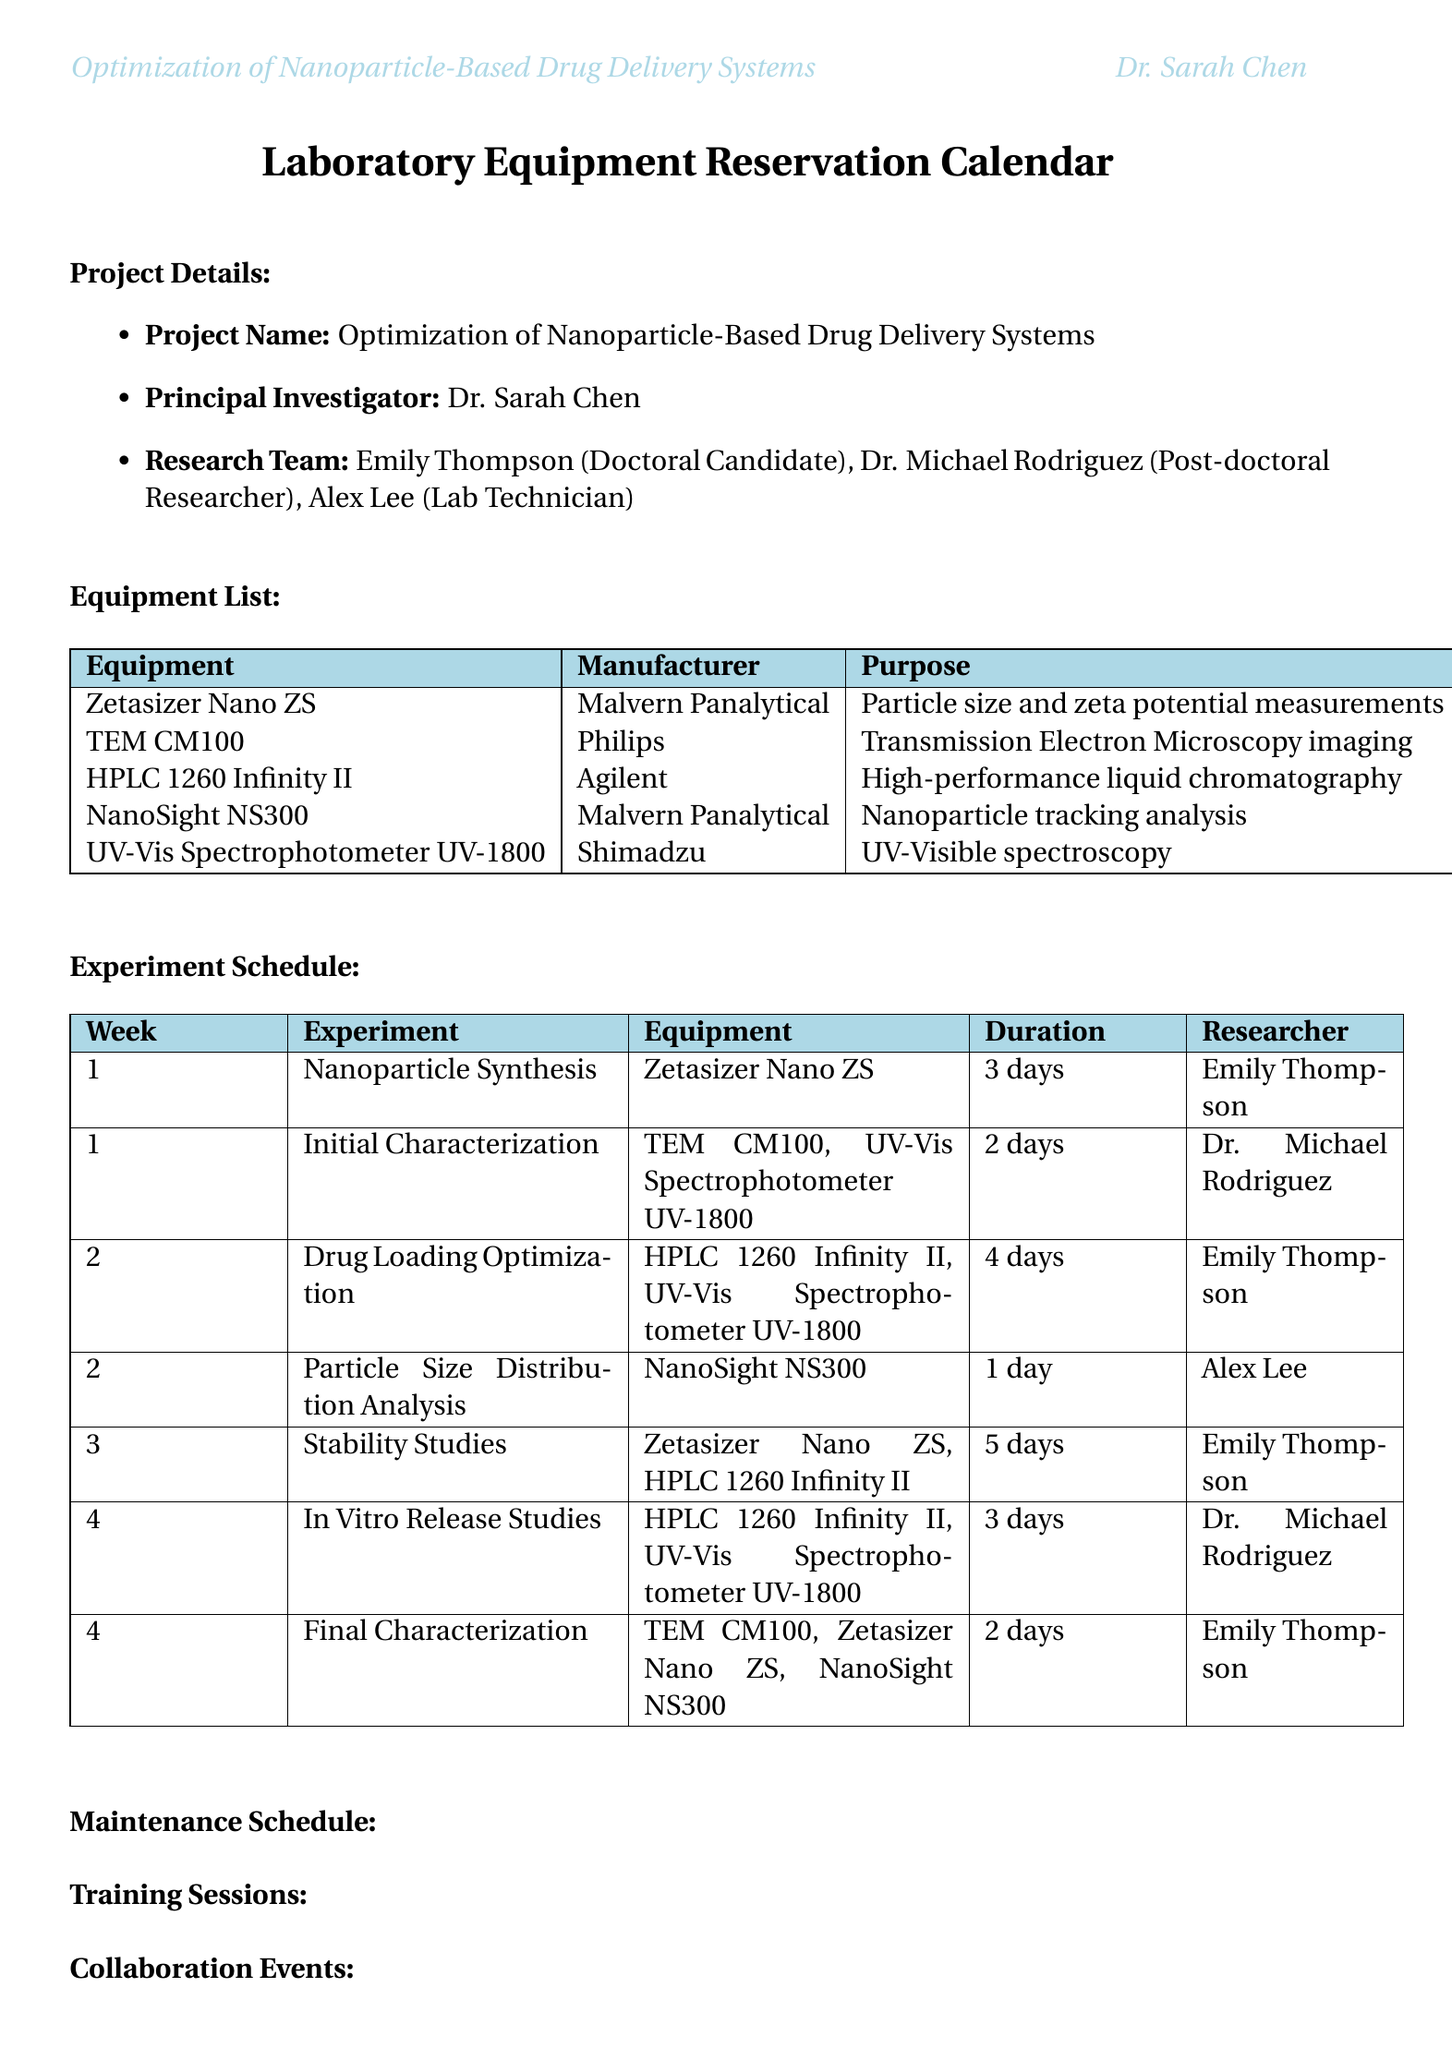what is the project name? The project name is listed at the beginning of the document under project details.
Answer: Optimization of Nanoparticle-Based Drug Delivery Systems who is the principal investigator? The principal investigator is mentioned in the project details section of the document.
Answer: Dr. Sarah Chen how many researchers are in the research team? The document lists the members of the research team in the project details section.
Answer: 3 what equipment is used for transmission electron microscopy imaging? The document specifies the purpose of each equipment in the equipment list section.
Answer: TEM CM100 which experiments take place in week 2? The experiment schedule lists experiments by week, allowing for the identification of week 2's experiments.
Answer: Drug Loading Optimization, Particle Size Distribution Analysis how long is the maintenance scheduled for the HPLC 1260 Infinity II? The maintenance schedule details the duration for each equipment's maintenance in the maintenance section.
Answer: 6 hours what equipment is needed for stability studies? The experiment schedule outlines which equipment is needed for each experiment in the document.
Answer: Zetasizer Nano ZS, HPLC 1260 Infinity II how many days does the final characterization take? The duration for each experiment is provided in the experiment schedule.
Answer: 2 days who attended the data analysis workshop? The attendees of collaboration events are listed in the collaboration events section.
Answer: Emily Thompson, Dr. Michael Rodriguez 